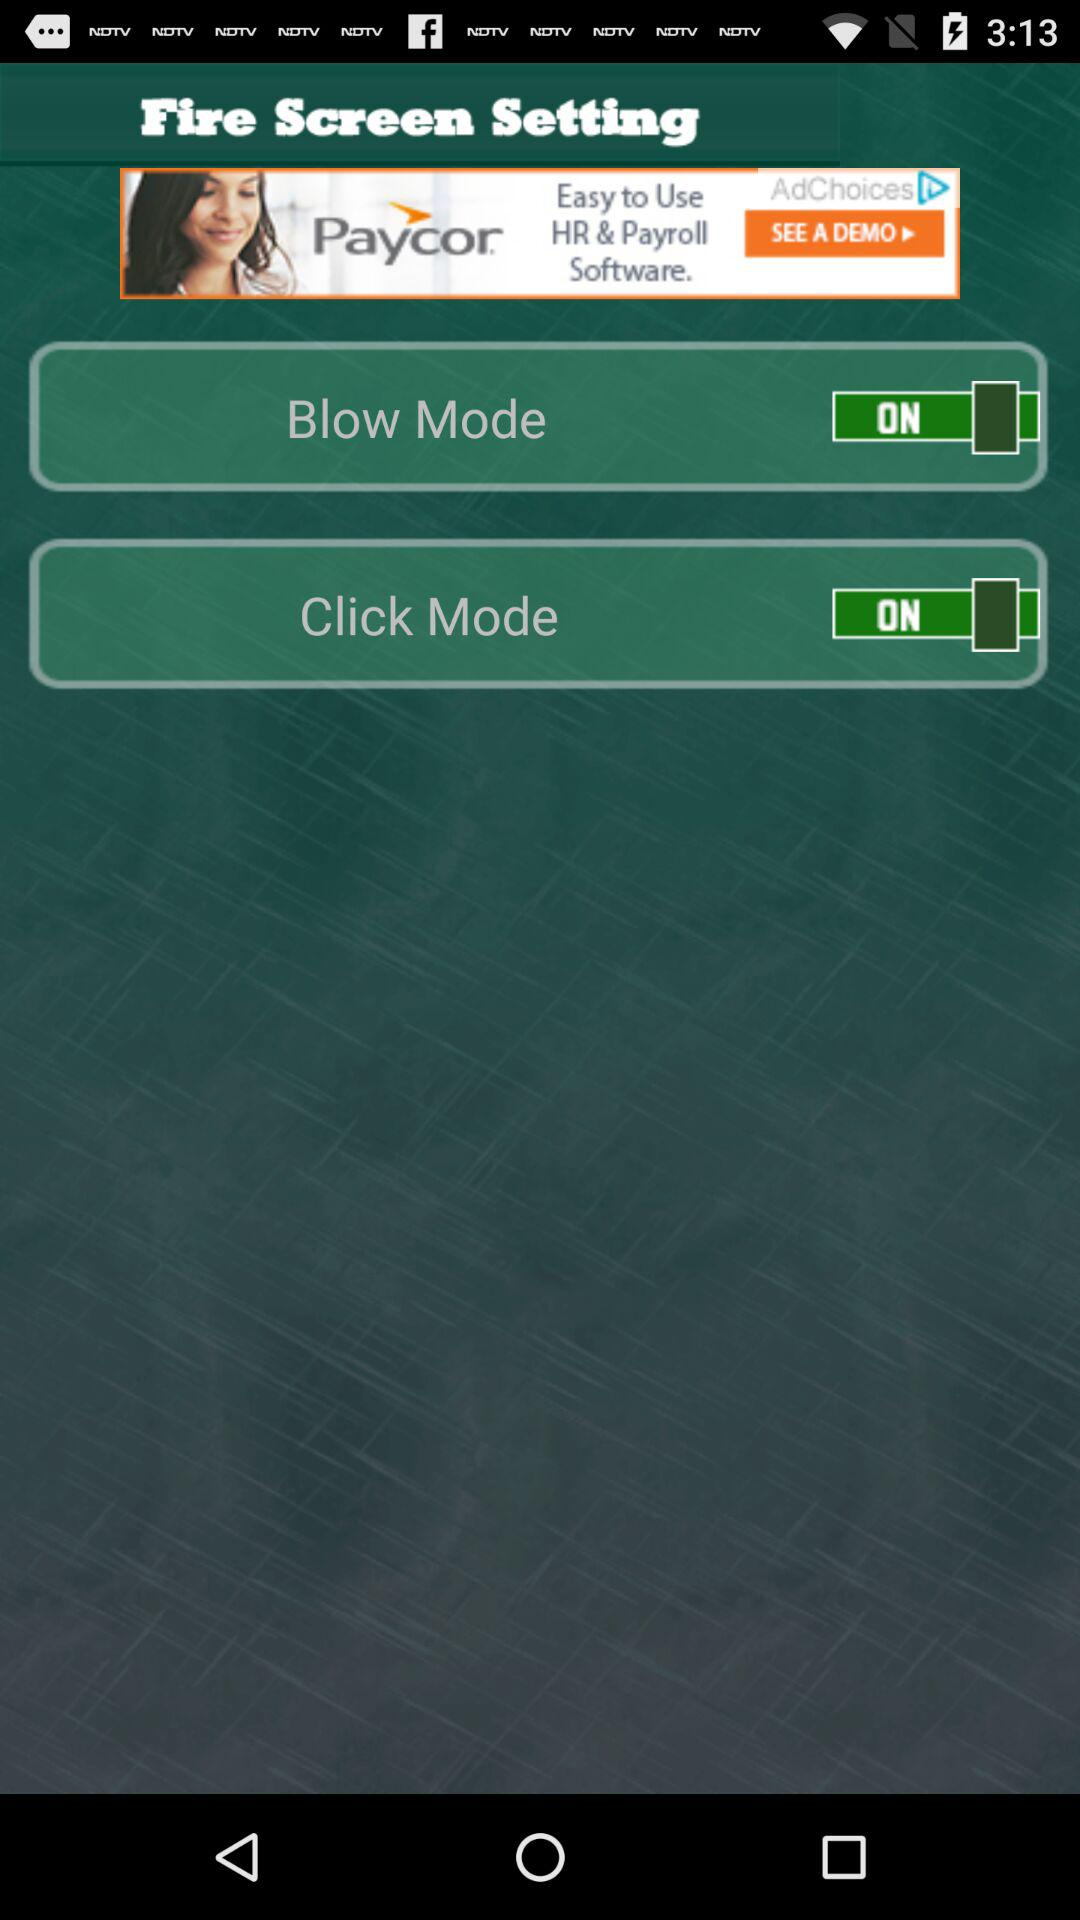What is the status of click mode? The status is ON. 